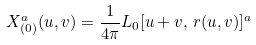<formula> <loc_0><loc_0><loc_500><loc_500>X _ { ( 0 ) } ^ { a } ( u , v ) = \frac { 1 } { 4 \pi } L _ { 0 } [ u + v , \, r ( u , v ) ] ^ { a }</formula> 